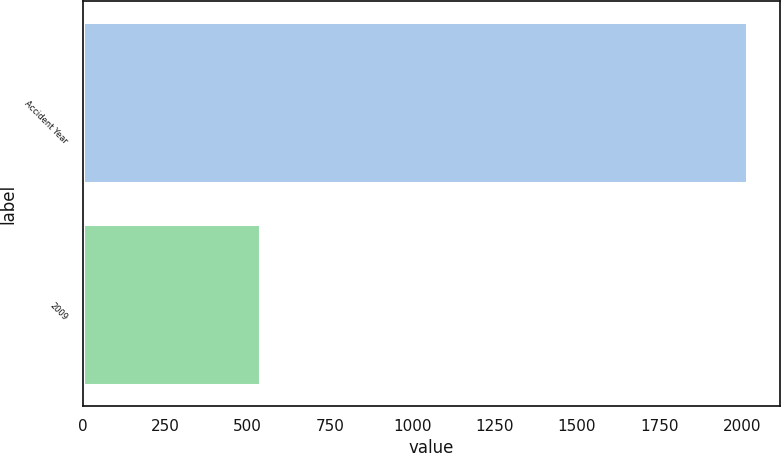<chart> <loc_0><loc_0><loc_500><loc_500><bar_chart><fcel>Accident Year<fcel>2009<nl><fcel>2015<fcel>539<nl></chart> 